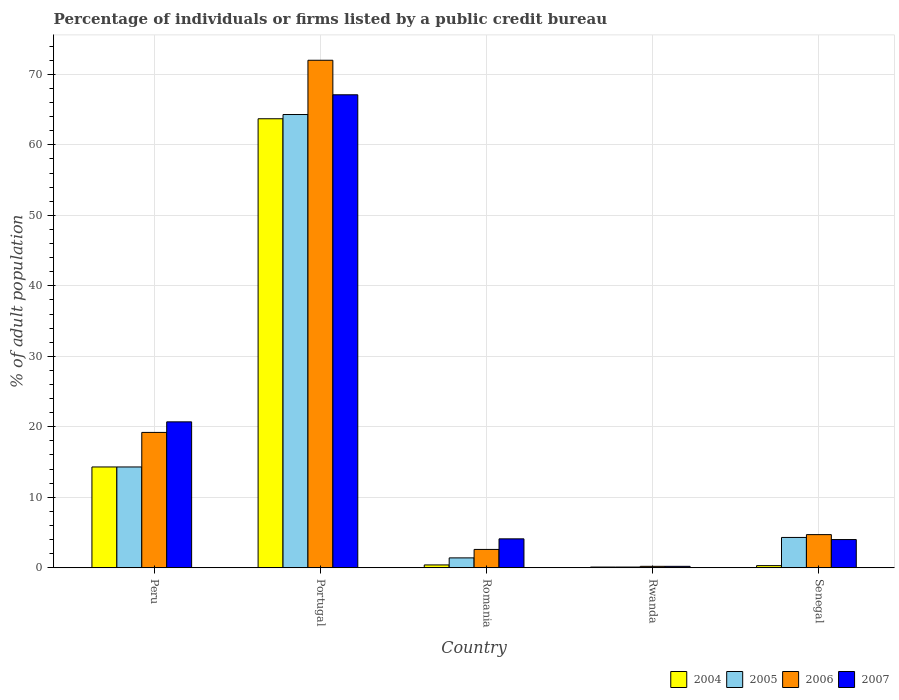How many different coloured bars are there?
Provide a succinct answer. 4. How many groups of bars are there?
Give a very brief answer. 5. Are the number of bars per tick equal to the number of legend labels?
Your answer should be compact. Yes. How many bars are there on the 1st tick from the right?
Provide a short and direct response. 4. What is the label of the 1st group of bars from the left?
Provide a succinct answer. Peru. What is the percentage of population listed by a public credit bureau in 2007 in Rwanda?
Ensure brevity in your answer.  0.2. Across all countries, what is the maximum percentage of population listed by a public credit bureau in 2005?
Your answer should be very brief. 64.3. Across all countries, what is the minimum percentage of population listed by a public credit bureau in 2007?
Your answer should be compact. 0.2. In which country was the percentage of population listed by a public credit bureau in 2005 maximum?
Give a very brief answer. Portugal. In which country was the percentage of population listed by a public credit bureau in 2004 minimum?
Provide a short and direct response. Rwanda. What is the total percentage of population listed by a public credit bureau in 2006 in the graph?
Provide a succinct answer. 98.7. What is the difference between the percentage of population listed by a public credit bureau in 2004 in Romania and that in Senegal?
Offer a very short reply. 0.1. What is the difference between the percentage of population listed by a public credit bureau in 2006 in Senegal and the percentage of population listed by a public credit bureau in 2004 in Rwanda?
Your answer should be compact. 4.6. What is the average percentage of population listed by a public credit bureau in 2005 per country?
Your answer should be compact. 16.88. In how many countries, is the percentage of population listed by a public credit bureau in 2007 greater than 48 %?
Give a very brief answer. 1. What is the ratio of the percentage of population listed by a public credit bureau in 2004 in Peru to that in Portugal?
Ensure brevity in your answer.  0.22. Is the percentage of population listed by a public credit bureau in 2007 in Rwanda less than that in Senegal?
Your answer should be compact. Yes. Is the difference between the percentage of population listed by a public credit bureau in 2006 in Peru and Romania greater than the difference between the percentage of population listed by a public credit bureau in 2004 in Peru and Romania?
Your answer should be compact. Yes. What is the difference between the highest and the second highest percentage of population listed by a public credit bureau in 2006?
Your answer should be very brief. 52.8. What is the difference between the highest and the lowest percentage of population listed by a public credit bureau in 2007?
Offer a very short reply. 66.9. In how many countries, is the percentage of population listed by a public credit bureau in 2007 greater than the average percentage of population listed by a public credit bureau in 2007 taken over all countries?
Ensure brevity in your answer.  2. Is the sum of the percentage of population listed by a public credit bureau in 2004 in Portugal and Rwanda greater than the maximum percentage of population listed by a public credit bureau in 2007 across all countries?
Ensure brevity in your answer.  No. What does the 3rd bar from the right in Senegal represents?
Your answer should be compact. 2005. Is it the case that in every country, the sum of the percentage of population listed by a public credit bureau in 2007 and percentage of population listed by a public credit bureau in 2005 is greater than the percentage of population listed by a public credit bureau in 2004?
Provide a succinct answer. Yes. Are all the bars in the graph horizontal?
Make the answer very short. No. Are the values on the major ticks of Y-axis written in scientific E-notation?
Your response must be concise. No. How are the legend labels stacked?
Provide a succinct answer. Horizontal. What is the title of the graph?
Your answer should be compact. Percentage of individuals or firms listed by a public credit bureau. What is the label or title of the Y-axis?
Your answer should be compact. % of adult population. What is the % of adult population of 2004 in Peru?
Provide a short and direct response. 14.3. What is the % of adult population in 2005 in Peru?
Give a very brief answer. 14.3. What is the % of adult population in 2006 in Peru?
Offer a terse response. 19.2. What is the % of adult population in 2007 in Peru?
Make the answer very short. 20.7. What is the % of adult population in 2004 in Portugal?
Make the answer very short. 63.7. What is the % of adult population in 2005 in Portugal?
Offer a terse response. 64.3. What is the % of adult population of 2006 in Portugal?
Your response must be concise. 72. What is the % of adult population of 2007 in Portugal?
Provide a succinct answer. 67.1. What is the % of adult population of 2004 in Romania?
Offer a terse response. 0.4. What is the % of adult population of 2005 in Romania?
Give a very brief answer. 1.4. What is the % of adult population of 2006 in Romania?
Make the answer very short. 2.6. What is the % of adult population in 2007 in Romania?
Your response must be concise. 4.1. What is the % of adult population of 2006 in Rwanda?
Your response must be concise. 0.2. What is the % of adult population in 2007 in Rwanda?
Your answer should be compact. 0.2. What is the % of adult population in 2006 in Senegal?
Your answer should be very brief. 4.7. What is the % of adult population in 2007 in Senegal?
Make the answer very short. 4. Across all countries, what is the maximum % of adult population in 2004?
Keep it short and to the point. 63.7. Across all countries, what is the maximum % of adult population in 2005?
Provide a succinct answer. 64.3. Across all countries, what is the maximum % of adult population of 2006?
Your answer should be compact. 72. Across all countries, what is the maximum % of adult population in 2007?
Offer a very short reply. 67.1. Across all countries, what is the minimum % of adult population in 2004?
Offer a very short reply. 0.1. Across all countries, what is the minimum % of adult population in 2006?
Keep it short and to the point. 0.2. What is the total % of adult population of 2004 in the graph?
Provide a short and direct response. 78.8. What is the total % of adult population in 2005 in the graph?
Give a very brief answer. 84.4. What is the total % of adult population in 2006 in the graph?
Make the answer very short. 98.7. What is the total % of adult population of 2007 in the graph?
Your answer should be compact. 96.1. What is the difference between the % of adult population in 2004 in Peru and that in Portugal?
Offer a terse response. -49.4. What is the difference between the % of adult population in 2005 in Peru and that in Portugal?
Keep it short and to the point. -50. What is the difference between the % of adult population of 2006 in Peru and that in Portugal?
Offer a terse response. -52.8. What is the difference between the % of adult population of 2007 in Peru and that in Portugal?
Provide a short and direct response. -46.4. What is the difference between the % of adult population in 2005 in Peru and that in Romania?
Provide a succinct answer. 12.9. What is the difference between the % of adult population in 2004 in Peru and that in Rwanda?
Keep it short and to the point. 14.2. What is the difference between the % of adult population of 2007 in Peru and that in Rwanda?
Ensure brevity in your answer.  20.5. What is the difference between the % of adult population of 2007 in Peru and that in Senegal?
Give a very brief answer. 16.7. What is the difference between the % of adult population in 2004 in Portugal and that in Romania?
Offer a very short reply. 63.3. What is the difference between the % of adult population of 2005 in Portugal and that in Romania?
Provide a short and direct response. 62.9. What is the difference between the % of adult population of 2006 in Portugal and that in Romania?
Make the answer very short. 69.4. What is the difference between the % of adult population in 2004 in Portugal and that in Rwanda?
Give a very brief answer. 63.6. What is the difference between the % of adult population in 2005 in Portugal and that in Rwanda?
Offer a terse response. 64.2. What is the difference between the % of adult population of 2006 in Portugal and that in Rwanda?
Make the answer very short. 71.8. What is the difference between the % of adult population of 2007 in Portugal and that in Rwanda?
Make the answer very short. 66.9. What is the difference between the % of adult population of 2004 in Portugal and that in Senegal?
Ensure brevity in your answer.  63.4. What is the difference between the % of adult population in 2006 in Portugal and that in Senegal?
Your response must be concise. 67.3. What is the difference between the % of adult population in 2007 in Portugal and that in Senegal?
Your answer should be compact. 63.1. What is the difference between the % of adult population of 2007 in Romania and that in Rwanda?
Your response must be concise. 3.9. What is the difference between the % of adult population of 2006 in Romania and that in Senegal?
Offer a very short reply. -2.1. What is the difference between the % of adult population in 2007 in Romania and that in Senegal?
Your answer should be very brief. 0.1. What is the difference between the % of adult population of 2004 in Rwanda and that in Senegal?
Your response must be concise. -0.2. What is the difference between the % of adult population in 2005 in Rwanda and that in Senegal?
Ensure brevity in your answer.  -4.2. What is the difference between the % of adult population of 2004 in Peru and the % of adult population of 2006 in Portugal?
Offer a very short reply. -57.7. What is the difference between the % of adult population in 2004 in Peru and the % of adult population in 2007 in Portugal?
Offer a terse response. -52.8. What is the difference between the % of adult population in 2005 in Peru and the % of adult population in 2006 in Portugal?
Your answer should be very brief. -57.7. What is the difference between the % of adult population of 2005 in Peru and the % of adult population of 2007 in Portugal?
Offer a terse response. -52.8. What is the difference between the % of adult population of 2006 in Peru and the % of adult population of 2007 in Portugal?
Offer a very short reply. -47.9. What is the difference between the % of adult population in 2004 in Peru and the % of adult population in 2006 in Romania?
Offer a terse response. 11.7. What is the difference between the % of adult population in 2004 in Peru and the % of adult population in 2007 in Romania?
Keep it short and to the point. 10.2. What is the difference between the % of adult population in 2005 in Peru and the % of adult population in 2006 in Romania?
Make the answer very short. 11.7. What is the difference between the % of adult population in 2005 in Peru and the % of adult population in 2007 in Romania?
Provide a succinct answer. 10.2. What is the difference between the % of adult population of 2006 in Peru and the % of adult population of 2007 in Romania?
Offer a terse response. 15.1. What is the difference between the % of adult population in 2004 in Peru and the % of adult population in 2005 in Rwanda?
Provide a succinct answer. 14.2. What is the difference between the % of adult population in 2004 in Peru and the % of adult population in 2006 in Rwanda?
Your answer should be very brief. 14.1. What is the difference between the % of adult population in 2005 in Peru and the % of adult population in 2006 in Rwanda?
Your answer should be compact. 14.1. What is the difference between the % of adult population of 2005 in Peru and the % of adult population of 2007 in Rwanda?
Make the answer very short. 14.1. What is the difference between the % of adult population of 2006 in Peru and the % of adult population of 2007 in Rwanda?
Ensure brevity in your answer.  19. What is the difference between the % of adult population in 2004 in Peru and the % of adult population in 2007 in Senegal?
Give a very brief answer. 10.3. What is the difference between the % of adult population of 2004 in Portugal and the % of adult population of 2005 in Romania?
Provide a short and direct response. 62.3. What is the difference between the % of adult population in 2004 in Portugal and the % of adult population in 2006 in Romania?
Give a very brief answer. 61.1. What is the difference between the % of adult population in 2004 in Portugal and the % of adult population in 2007 in Romania?
Make the answer very short. 59.6. What is the difference between the % of adult population of 2005 in Portugal and the % of adult population of 2006 in Romania?
Offer a terse response. 61.7. What is the difference between the % of adult population in 2005 in Portugal and the % of adult population in 2007 in Romania?
Keep it short and to the point. 60.2. What is the difference between the % of adult population of 2006 in Portugal and the % of adult population of 2007 in Romania?
Ensure brevity in your answer.  67.9. What is the difference between the % of adult population in 2004 in Portugal and the % of adult population in 2005 in Rwanda?
Provide a short and direct response. 63.6. What is the difference between the % of adult population in 2004 in Portugal and the % of adult population in 2006 in Rwanda?
Make the answer very short. 63.5. What is the difference between the % of adult population of 2004 in Portugal and the % of adult population of 2007 in Rwanda?
Keep it short and to the point. 63.5. What is the difference between the % of adult population in 2005 in Portugal and the % of adult population in 2006 in Rwanda?
Ensure brevity in your answer.  64.1. What is the difference between the % of adult population in 2005 in Portugal and the % of adult population in 2007 in Rwanda?
Provide a short and direct response. 64.1. What is the difference between the % of adult population of 2006 in Portugal and the % of adult population of 2007 in Rwanda?
Your response must be concise. 71.8. What is the difference between the % of adult population of 2004 in Portugal and the % of adult population of 2005 in Senegal?
Offer a very short reply. 59.4. What is the difference between the % of adult population in 2004 in Portugal and the % of adult population in 2007 in Senegal?
Offer a very short reply. 59.7. What is the difference between the % of adult population in 2005 in Portugal and the % of adult population in 2006 in Senegal?
Your answer should be compact. 59.6. What is the difference between the % of adult population of 2005 in Portugal and the % of adult population of 2007 in Senegal?
Offer a terse response. 60.3. What is the difference between the % of adult population in 2005 in Romania and the % of adult population in 2007 in Rwanda?
Ensure brevity in your answer.  1.2. What is the difference between the % of adult population in 2006 in Romania and the % of adult population in 2007 in Rwanda?
Give a very brief answer. 2.4. What is the difference between the % of adult population of 2004 in Romania and the % of adult population of 2005 in Senegal?
Give a very brief answer. -3.9. What is the difference between the % of adult population of 2004 in Romania and the % of adult population of 2007 in Senegal?
Offer a very short reply. -3.6. What is the difference between the % of adult population in 2004 in Rwanda and the % of adult population in 2006 in Senegal?
Your answer should be compact. -4.6. What is the difference between the % of adult population in 2004 in Rwanda and the % of adult population in 2007 in Senegal?
Provide a short and direct response. -3.9. What is the difference between the % of adult population in 2005 in Rwanda and the % of adult population in 2006 in Senegal?
Your response must be concise. -4.6. What is the difference between the % of adult population in 2005 in Rwanda and the % of adult population in 2007 in Senegal?
Offer a very short reply. -3.9. What is the difference between the % of adult population of 2006 in Rwanda and the % of adult population of 2007 in Senegal?
Make the answer very short. -3.8. What is the average % of adult population in 2004 per country?
Provide a succinct answer. 15.76. What is the average % of adult population of 2005 per country?
Your answer should be very brief. 16.88. What is the average % of adult population of 2006 per country?
Ensure brevity in your answer.  19.74. What is the average % of adult population in 2007 per country?
Provide a succinct answer. 19.22. What is the difference between the % of adult population of 2004 and % of adult population of 2006 in Peru?
Ensure brevity in your answer.  -4.9. What is the difference between the % of adult population of 2004 and % of adult population of 2007 in Portugal?
Provide a succinct answer. -3.4. What is the difference between the % of adult population of 2005 and % of adult population of 2006 in Portugal?
Make the answer very short. -7.7. What is the difference between the % of adult population in 2005 and % of adult population in 2007 in Portugal?
Your answer should be compact. -2.8. What is the difference between the % of adult population of 2006 and % of adult population of 2007 in Portugal?
Give a very brief answer. 4.9. What is the difference between the % of adult population in 2005 and % of adult population in 2007 in Romania?
Provide a succinct answer. -2.7. What is the difference between the % of adult population in 2006 and % of adult population in 2007 in Romania?
Your answer should be compact. -1.5. What is the difference between the % of adult population in 2004 and % of adult population in 2005 in Rwanda?
Give a very brief answer. 0. What is the difference between the % of adult population in 2004 and % of adult population in 2007 in Rwanda?
Offer a very short reply. -0.1. What is the difference between the % of adult population of 2005 and % of adult population of 2006 in Rwanda?
Give a very brief answer. -0.1. What is the difference between the % of adult population of 2006 and % of adult population of 2007 in Rwanda?
Provide a short and direct response. 0. What is the difference between the % of adult population in 2004 and % of adult population in 2005 in Senegal?
Your response must be concise. -4. What is the difference between the % of adult population in 2004 and % of adult population in 2006 in Senegal?
Make the answer very short. -4.4. What is the difference between the % of adult population of 2004 and % of adult population of 2007 in Senegal?
Your answer should be compact. -3.7. What is the difference between the % of adult population of 2005 and % of adult population of 2006 in Senegal?
Offer a very short reply. -0.4. What is the difference between the % of adult population of 2005 and % of adult population of 2007 in Senegal?
Your answer should be very brief. 0.3. What is the ratio of the % of adult population in 2004 in Peru to that in Portugal?
Offer a very short reply. 0.22. What is the ratio of the % of adult population of 2005 in Peru to that in Portugal?
Ensure brevity in your answer.  0.22. What is the ratio of the % of adult population of 2006 in Peru to that in Portugal?
Offer a terse response. 0.27. What is the ratio of the % of adult population in 2007 in Peru to that in Portugal?
Give a very brief answer. 0.31. What is the ratio of the % of adult population of 2004 in Peru to that in Romania?
Offer a terse response. 35.75. What is the ratio of the % of adult population of 2005 in Peru to that in Romania?
Provide a short and direct response. 10.21. What is the ratio of the % of adult population in 2006 in Peru to that in Romania?
Make the answer very short. 7.38. What is the ratio of the % of adult population in 2007 in Peru to that in Romania?
Your response must be concise. 5.05. What is the ratio of the % of adult population of 2004 in Peru to that in Rwanda?
Make the answer very short. 143. What is the ratio of the % of adult population in 2005 in Peru to that in Rwanda?
Your response must be concise. 143. What is the ratio of the % of adult population of 2006 in Peru to that in Rwanda?
Keep it short and to the point. 96. What is the ratio of the % of adult population in 2007 in Peru to that in Rwanda?
Keep it short and to the point. 103.5. What is the ratio of the % of adult population of 2004 in Peru to that in Senegal?
Your answer should be very brief. 47.67. What is the ratio of the % of adult population in 2005 in Peru to that in Senegal?
Your answer should be compact. 3.33. What is the ratio of the % of adult population in 2006 in Peru to that in Senegal?
Your response must be concise. 4.09. What is the ratio of the % of adult population of 2007 in Peru to that in Senegal?
Your answer should be very brief. 5.17. What is the ratio of the % of adult population of 2004 in Portugal to that in Romania?
Offer a very short reply. 159.25. What is the ratio of the % of adult population of 2005 in Portugal to that in Romania?
Keep it short and to the point. 45.93. What is the ratio of the % of adult population of 2006 in Portugal to that in Romania?
Offer a terse response. 27.69. What is the ratio of the % of adult population in 2007 in Portugal to that in Romania?
Provide a succinct answer. 16.37. What is the ratio of the % of adult population of 2004 in Portugal to that in Rwanda?
Your response must be concise. 637. What is the ratio of the % of adult population of 2005 in Portugal to that in Rwanda?
Your response must be concise. 643. What is the ratio of the % of adult population of 2006 in Portugal to that in Rwanda?
Make the answer very short. 360. What is the ratio of the % of adult population in 2007 in Portugal to that in Rwanda?
Offer a terse response. 335.5. What is the ratio of the % of adult population in 2004 in Portugal to that in Senegal?
Your response must be concise. 212.33. What is the ratio of the % of adult population of 2005 in Portugal to that in Senegal?
Your response must be concise. 14.95. What is the ratio of the % of adult population of 2006 in Portugal to that in Senegal?
Offer a very short reply. 15.32. What is the ratio of the % of adult population in 2007 in Portugal to that in Senegal?
Offer a very short reply. 16.77. What is the ratio of the % of adult population of 2005 in Romania to that in Rwanda?
Provide a succinct answer. 14. What is the ratio of the % of adult population of 2006 in Romania to that in Rwanda?
Provide a succinct answer. 13. What is the ratio of the % of adult population of 2007 in Romania to that in Rwanda?
Your answer should be compact. 20.5. What is the ratio of the % of adult population in 2005 in Romania to that in Senegal?
Your response must be concise. 0.33. What is the ratio of the % of adult population of 2006 in Romania to that in Senegal?
Your answer should be compact. 0.55. What is the ratio of the % of adult population of 2005 in Rwanda to that in Senegal?
Make the answer very short. 0.02. What is the ratio of the % of adult population of 2006 in Rwanda to that in Senegal?
Ensure brevity in your answer.  0.04. What is the ratio of the % of adult population in 2007 in Rwanda to that in Senegal?
Offer a very short reply. 0.05. What is the difference between the highest and the second highest % of adult population in 2004?
Ensure brevity in your answer.  49.4. What is the difference between the highest and the second highest % of adult population of 2006?
Ensure brevity in your answer.  52.8. What is the difference between the highest and the second highest % of adult population in 2007?
Provide a short and direct response. 46.4. What is the difference between the highest and the lowest % of adult population in 2004?
Ensure brevity in your answer.  63.6. What is the difference between the highest and the lowest % of adult population of 2005?
Your answer should be very brief. 64.2. What is the difference between the highest and the lowest % of adult population in 2006?
Offer a terse response. 71.8. What is the difference between the highest and the lowest % of adult population of 2007?
Provide a short and direct response. 66.9. 